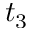Convert formula to latex. <formula><loc_0><loc_0><loc_500><loc_500>t _ { 3 }</formula> 